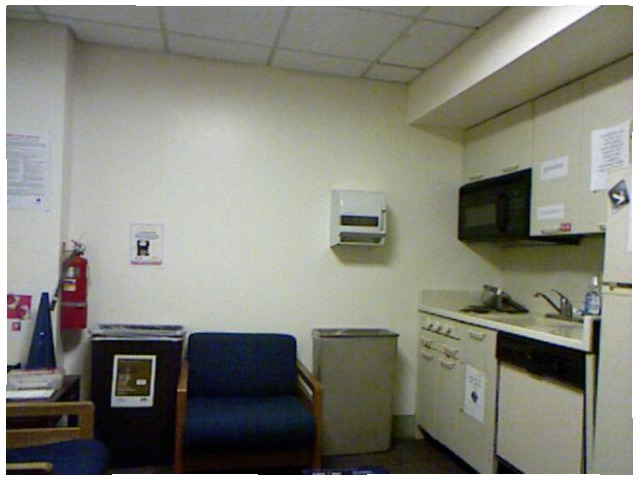<image>
Is the fire extinguisher on the wall? Yes. Looking at the image, I can see the fire extinguisher is positioned on top of the wall, with the wall providing support. 